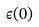<formula> <loc_0><loc_0><loc_500><loc_500>\epsilon ( 0 )</formula> 